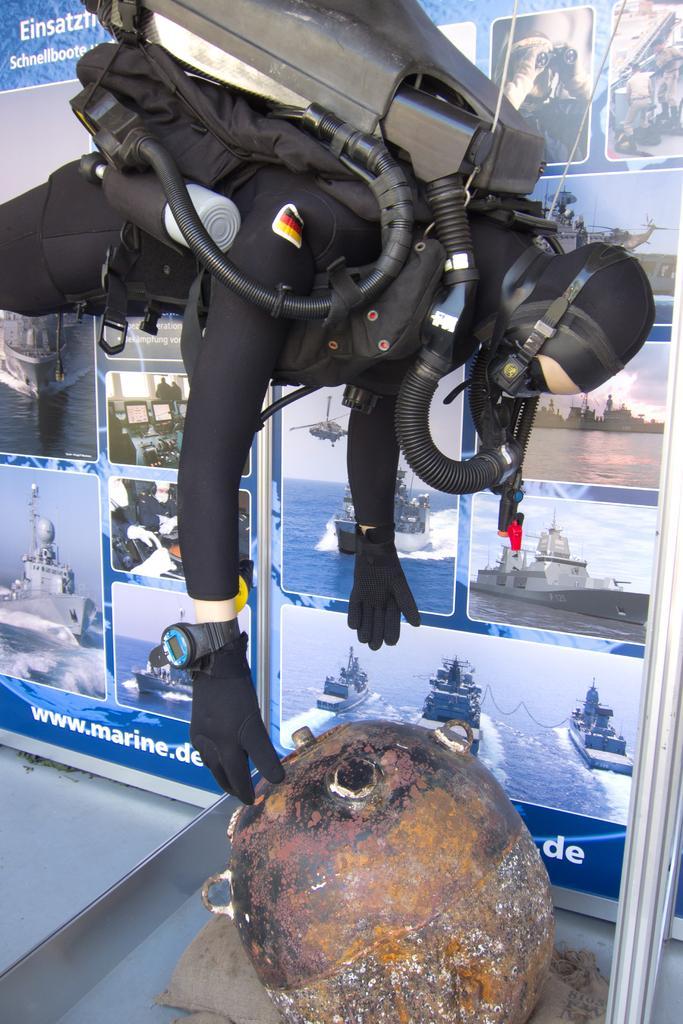Describe this image in one or two sentences. In the center of the image we can see one person wearing a helmet and some other object. In front of him, we can see one stone. In the background there is a banner and a few other objects. On the banner, we can see ships, water and some text. 